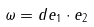Convert formula to latex. <formula><loc_0><loc_0><loc_500><loc_500>\omega = d e _ { 1 } \cdot e _ { 2 }</formula> 